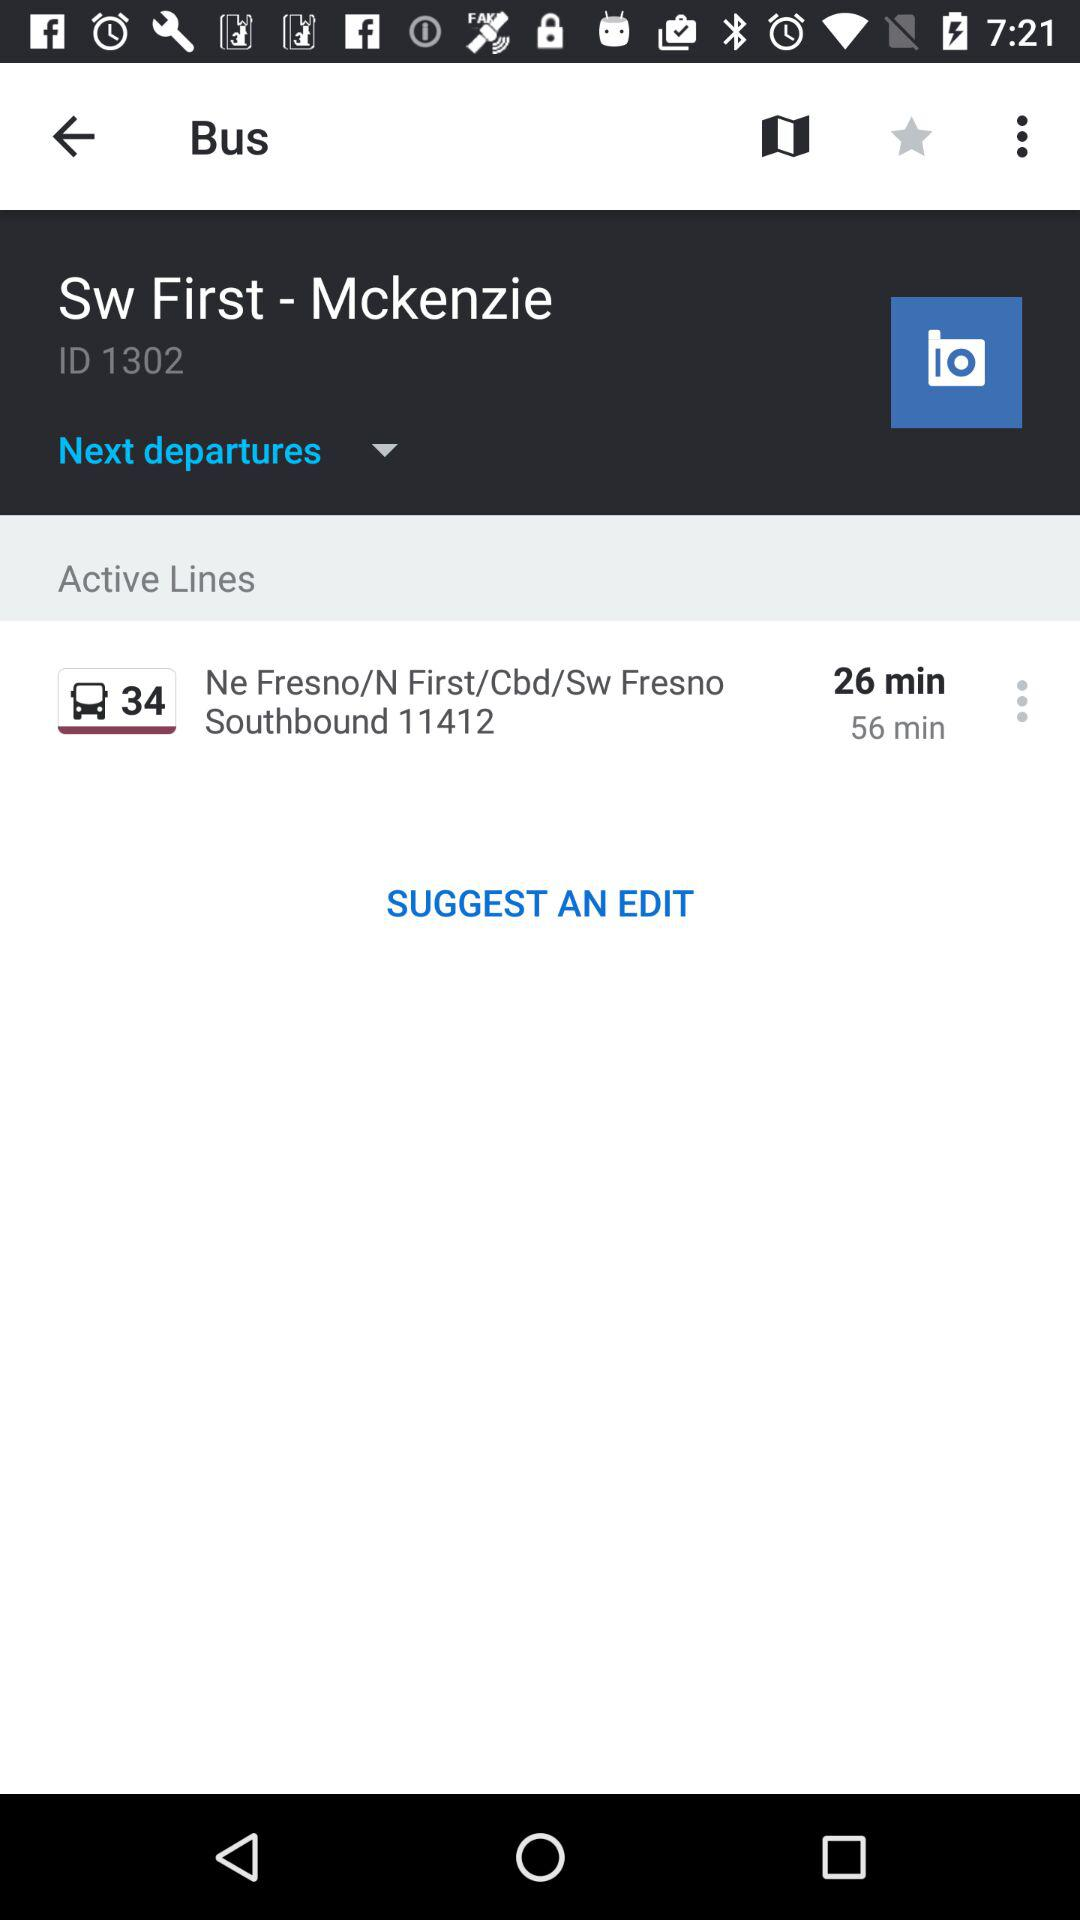How many minutes are there between the two departure times?
Answer the question using a single word or phrase. 30 